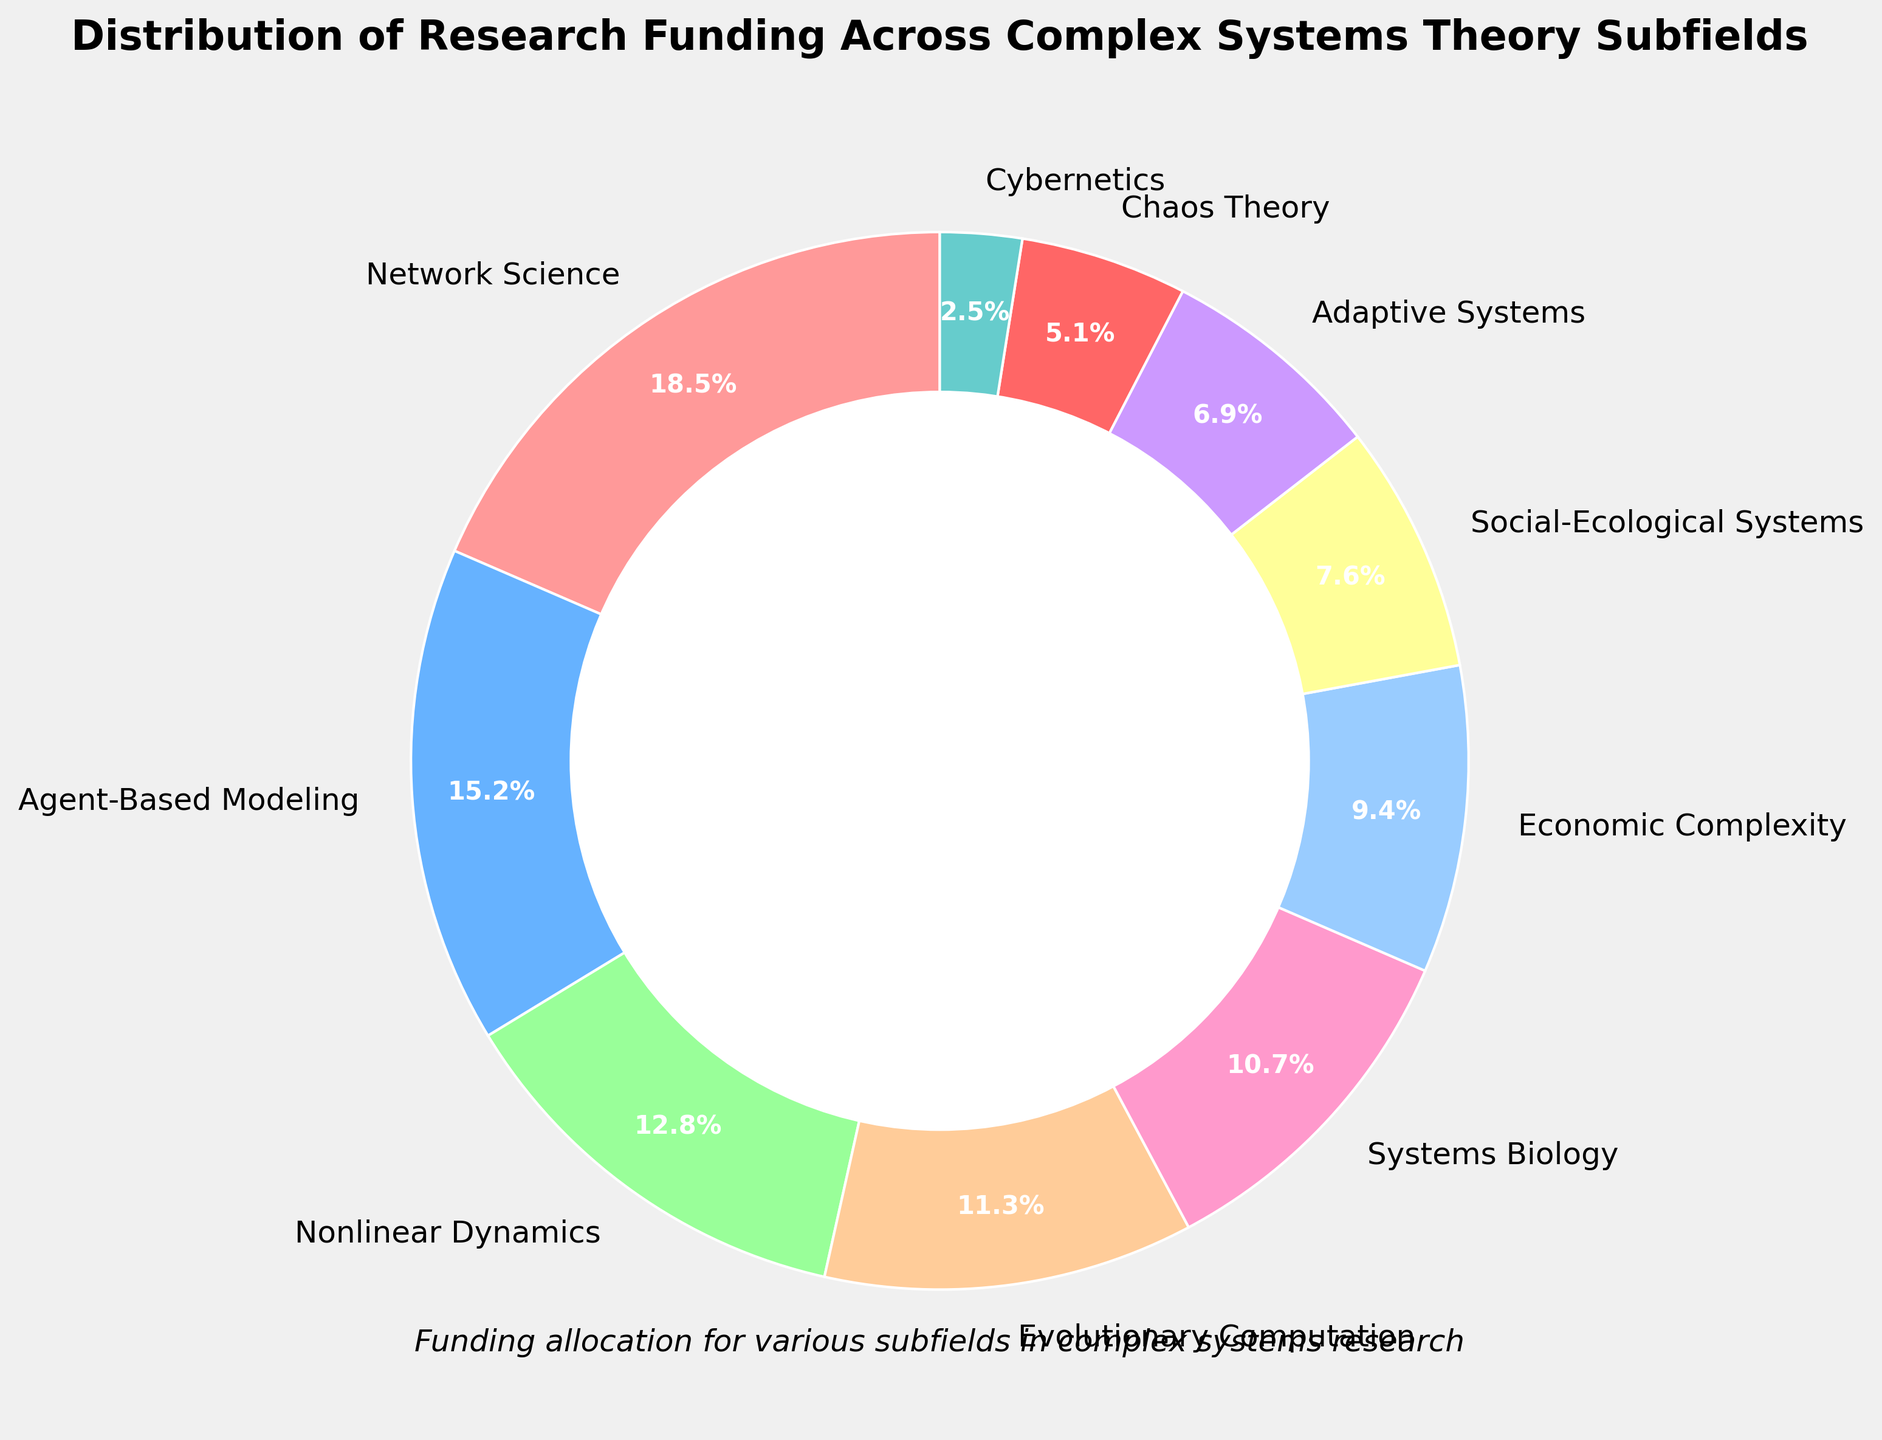Which subfield has the highest percentage of research funding? The figure indicates that the percentage of research funding is divided among various subfields. By visually inspecting the pie chart, we can see that the largest wedge corresponds to the subfield "Network Science."
Answer: Network Science What's the combined funding percentage for "Nonlinear Dynamics," "Systems Biology," and "Chaos Theory"? To find the combined funding percentage, we add the percentages for the subfields "Nonlinear Dynamics" (12.8%), "Systems Biology" (10.7%), and "Chaos Theory" (5.1%). The calculation is 12.8 + 10.7 + 5.1 = 28.6%.
Answer: 28.6% Which subfield receives slightly less funding than "Agent-Based Modeling"? We compare the funding percentages. "Agent-Based Modeling" receives 15.2%. The subfield "Network Science" receives more (18.5%), and "Nonlinear Dynamics" receives slightly less (12.8%). Therefore, "Nonlinear Dynamics" is the subfield with slightly less funding.
Answer: Nonlinear Dynamics How much more funding does "Economic Complexity" get compared to "Cybernetics"? To determine the difference in funding, subtract the percentage of "Cybernetics" (2.5%) from the percentage of "Economic Complexity" (9.4%). The difference is 9.4 - 2.5 = 6.9%.
Answer: 6.9% Which color represents "Adaptive Systems"? By visually examining the pie chart and its legend, we can identify that "Adaptive Systems" is represented by the color green.
Answer: Green Is the funding for "Social-Ecological Systems" more than, less than, or equal to that for "Economic Complexity"? Comparing the provided percentages, "Social-Ecological Systems" receives 7.6% while "Economic Complexity" receives 9.4%. Since 7.6 is less than 9.4, the funding for "Social-Ecological Systems" is less than that for "Economic Complexity."
Answer: Less than What is the average funding percentage of the subfields that receive more than 10% of funding? The subfields that receive more than 10% include "Network Science" (18.5%), "Agent-Based Modeling" (15.2%), "Nonlinear Dynamics" (12.8%), "Evolutionary Computation" (11.3%), and "Systems Biology" (10.7%). Their average funding is calculated as (18.5 + 15.2 + 12.8 + 11.3 + 10.7) / 5 = 68.5 / 5 = 13.7%.
Answer: 13.7% What is the smallest wedge in the pie chart? The smallest wedge corresponds to the subfield with the lowest percentage, which is "Cybernetics" with 2.5%.
Answer: Cybernetics Does any subfield get twice as much funding as "Chaos Theory"? "Chaos Theory" receives 5.1%. We look for subfields with double this amount (5.1 * 2 = 10.2%). Subfields exceeding 10.2% include "Network Science" (18.5%), "Agent-Based Modeling" (15.2%), "Nonlinear Dynamics" (12.8%), "Evolutionary Computation" (11.3%), and "Systems Biology" (10.7%). Thus, several subfields receive more than double the funding of "Chaos Theory."
Answer: Yes 